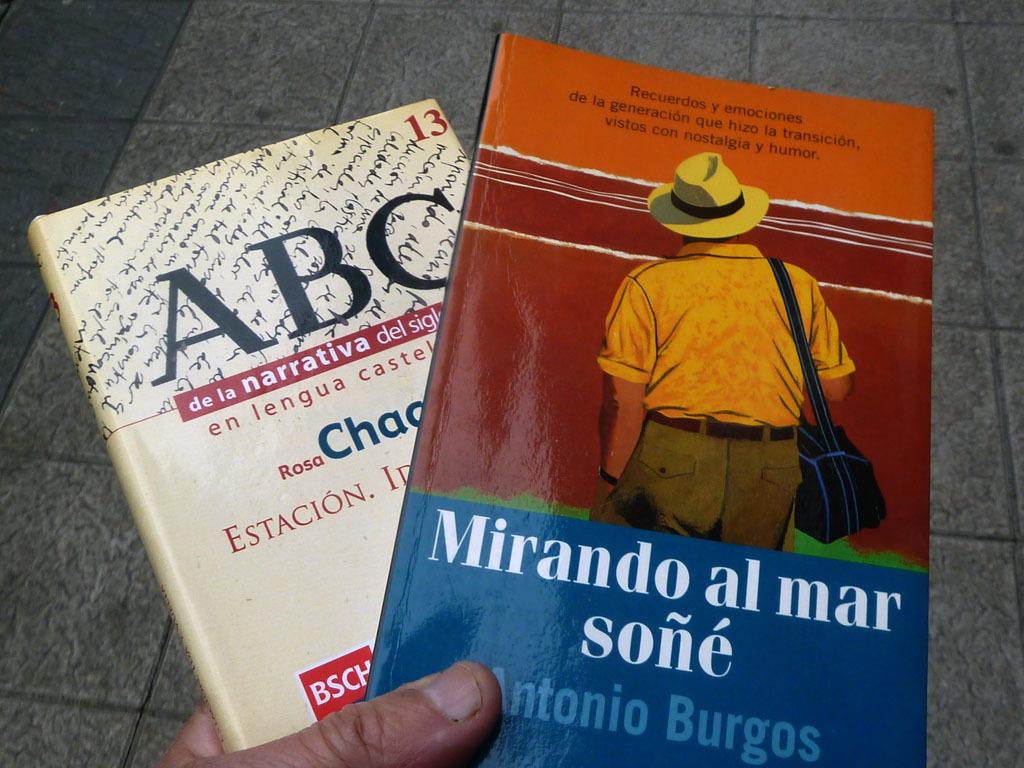What is the title of the book with the picture of the man with a hat?
Your response must be concise. Mirando al mar sone. What is the title of the white book?
Keep it short and to the point. Abc. 